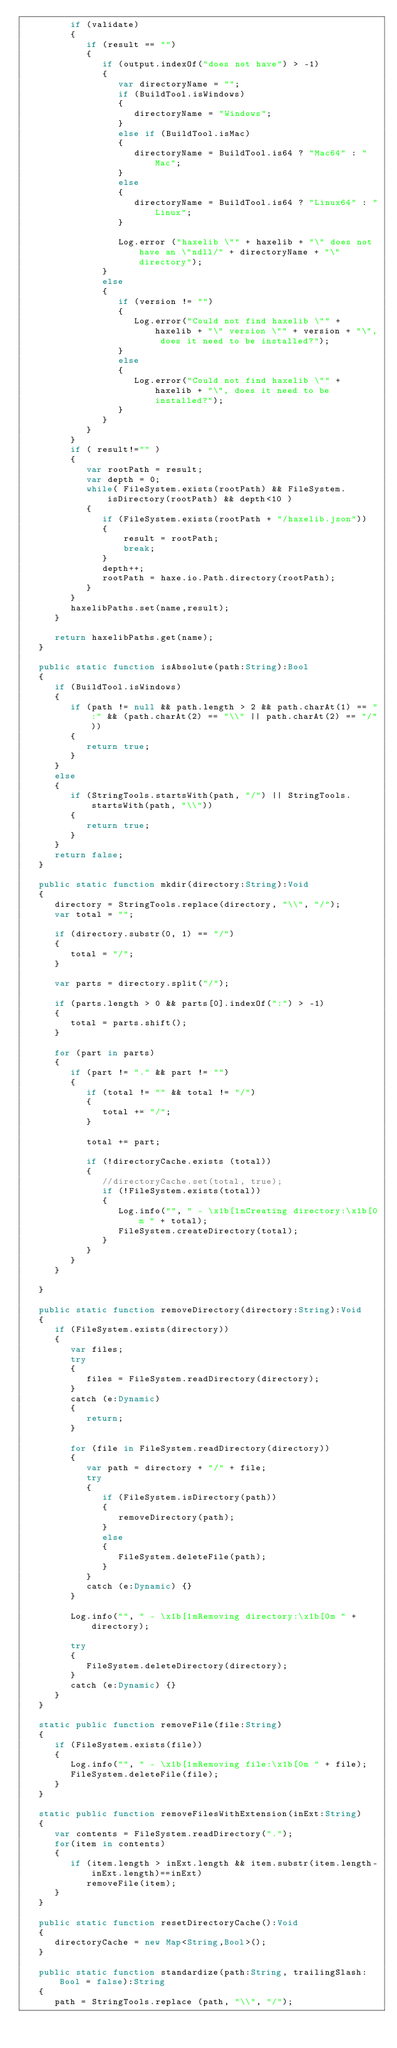<code> <loc_0><loc_0><loc_500><loc_500><_Haxe_>         if (validate)
         {
            if (result == "")
            {
               if (output.indexOf("does not have") > -1)
               {
                  var directoryName = "";
                  if (BuildTool.isWindows)
                  {
                     directoryName = "Windows";
                  }
                  else if (BuildTool.isMac)
                  {
                     directoryName = BuildTool.is64 ? "Mac64" : "Mac"; 
                  }
                  else
                  {
                     directoryName = BuildTool.is64 ? "Linux64" : "Linux";
                  }
                  
                  Log.error ("haxelib \"" + haxelib + "\" does not have an \"ndll/" + directoryName + "\" directory");
               }
               else
               {
                  if (version != "")
                  {
                     Log.error("Could not find haxelib \"" + haxelib + "\" version \"" + version + "\", does it need to be installed?");
                  }
                  else
                  {
                     Log.error("Could not find haxelib \"" + haxelib + "\", does it need to be installed?");
                  }
               }
            }
         }
         if ( result!="" )
         {
            var rootPath = result;
            var depth = 0;
            while( FileSystem.exists(rootPath) && FileSystem.isDirectory(rootPath) && depth<10 )
            {
               if (FileSystem.exists(rootPath + "/haxelib.json"))
               {
                   result = rootPath;
                   break;
               }
               depth++;
               rootPath = haxe.io.Path.directory(rootPath);
            }
         }
         haxelibPaths.set(name,result);
      }
      
      return haxelibPaths.get(name);
   }

   public static function isAbsolute(path:String):Bool
   {
      if (BuildTool.isWindows)
      {
         if (path != null && path.length > 2 && path.charAt(1) == ":" && (path.charAt(2) == "\\" || path.charAt(2) == "/"))
         {
            return true;
         }
      }
      else
      {
         if (StringTools.startsWith(path, "/") || StringTools.startsWith(path, "\\"))
         {
            return true;
         }
      }
      return false;
   }

   public static function mkdir(directory:String):Void
   {
      directory = StringTools.replace(directory, "\\", "/");
      var total = "";
      
      if (directory.substr(0, 1) == "/")
      {
         total = "/";   
      }
      
      var parts = directory.split("/");
      
      if (parts.length > 0 && parts[0].indexOf(":") > -1)
      {
         total = parts.shift();
      }
      
      for (part in parts)
      {
         if (part != "." && part != "")
         {
            if (total != "" && total != "/")
            {
               total += "/";  
            }
            
            total += part;
            
            if (!directoryCache.exists (total))
            {
               //directoryCache.set(total, true);
               if (!FileSystem.exists(total))
               {
                  Log.info("", " - \x1b[1mCreating directory:\x1b[0m " + total);
                  FileSystem.createDirectory(total);
               }
            }
         }
      }
      
   }

   public static function removeDirectory(directory:String):Void
   {
      if (FileSystem.exists(directory))
      {
         var files;
         try
         {
            files = FileSystem.readDirectory(directory);
         }
         catch (e:Dynamic)
         {   
            return;  
         }
         
         for (file in FileSystem.readDirectory(directory))
         {   
            var path = directory + "/" + file;
            try
            {   
               if (FileSystem.isDirectory(path))
               {   
                  removeDirectory(path);
               }
               else
               {
                  FileSystem.deleteFile(path);
               }
            }
            catch (e:Dynamic) {}
         }
         
         Log.info("", " - \x1b[1mRemoving directory:\x1b[0m " + directory);
         
         try
         {   
            FileSystem.deleteDirectory(directory);
         }
         catch (e:Dynamic) {}
      }
   }

   static public function removeFile(file:String)
   {
      if (FileSystem.exists(file))
      {
         Log.info("", " - \x1b[1mRemoving file:\x1b[0m " + file);
         FileSystem.deleteFile(file);
      }
   }

   static public function removeFilesWithExtension(inExt:String)
   {
      var contents = FileSystem.readDirectory(".");
      for(item in contents)
      {
         if (item.length > inExt.length && item.substr(item.length-inExt.length)==inExt)
            removeFile(item);
      }
   }

   public static function resetDirectoryCache():Void
   {
      directoryCache = new Map<String,Bool>();
   }

   public static function standardize(path:String, trailingSlash:Bool = false):String
   {
      path = StringTools.replace (path, "\\", "/");</code> 